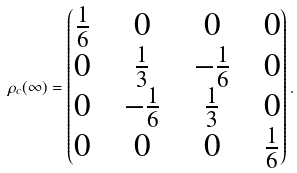<formula> <loc_0><loc_0><loc_500><loc_500>\rho _ { c } ( \infty ) = \begin{pmatrix} \frac { 1 } { 6 } & & 0 & & 0 & & 0 \\ 0 & & \frac { 1 } { 3 } & & - \frac { 1 } { 6 } & & 0 \\ 0 & & - \frac { 1 } { 6 } & & \frac { 1 } { 3 } & & 0 \\ 0 & & 0 & & 0 & & \frac { 1 } { 6 } \end{pmatrix} .</formula> 